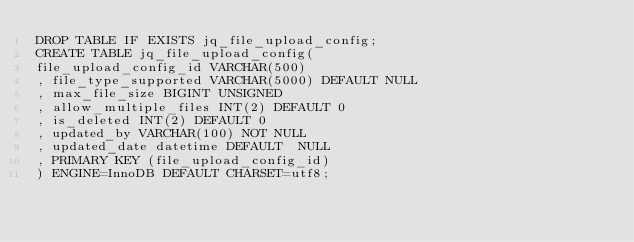Convert code to text. <code><loc_0><loc_0><loc_500><loc_500><_SQL_>DROP TABLE IF EXISTS jq_file_upload_config;
CREATE TABLE jq_file_upload_config( 
file_upload_config_id VARCHAR(500)
, file_type_supported VARCHAR(5000) DEFAULT NULL
, max_file_size BIGINT UNSIGNED
, allow_multiple_files INT(2) DEFAULT 0
, is_deleted INT(2) DEFAULT 0
, updated_by VARCHAR(100) NOT NULL
, updated_date datetime DEFAULT  NULL
, PRIMARY KEY (file_upload_config_id)
) ENGINE=InnoDB DEFAULT CHARSET=utf8;</code> 